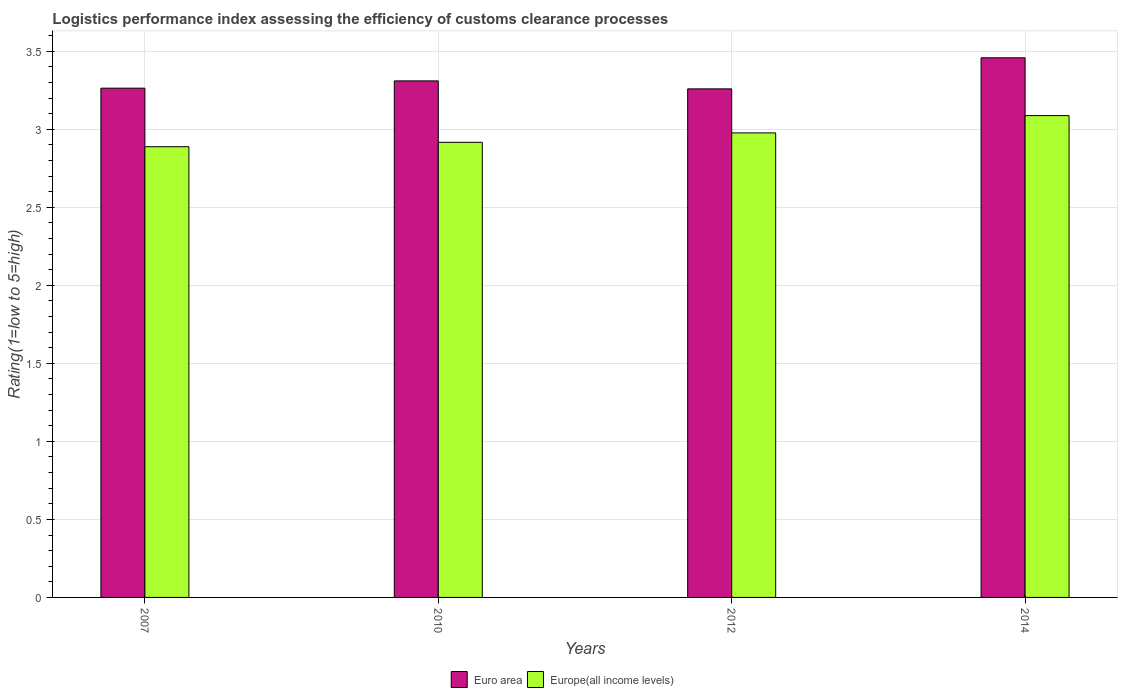How many groups of bars are there?
Provide a short and direct response. 4. How many bars are there on the 4th tick from the right?
Your answer should be compact. 2. In how many cases, is the number of bars for a given year not equal to the number of legend labels?
Keep it short and to the point. 0. What is the Logistic performance index in Euro area in 2014?
Make the answer very short. 3.46. Across all years, what is the maximum Logistic performance index in Euro area?
Keep it short and to the point. 3.46. Across all years, what is the minimum Logistic performance index in Europe(all income levels)?
Your answer should be compact. 2.89. In which year was the Logistic performance index in Euro area maximum?
Make the answer very short. 2014. What is the total Logistic performance index in Euro area in the graph?
Provide a succinct answer. 13.29. What is the difference between the Logistic performance index in Europe(all income levels) in 2010 and that in 2014?
Ensure brevity in your answer.  -0.17. What is the difference between the Logistic performance index in Europe(all income levels) in 2010 and the Logistic performance index in Euro area in 2012?
Your response must be concise. -0.34. What is the average Logistic performance index in Euro area per year?
Provide a succinct answer. 3.32. In the year 2014, what is the difference between the Logistic performance index in Euro area and Logistic performance index in Europe(all income levels)?
Keep it short and to the point. 0.37. What is the ratio of the Logistic performance index in Euro area in 2012 to that in 2014?
Your response must be concise. 0.94. Is the Logistic performance index in Europe(all income levels) in 2007 less than that in 2010?
Make the answer very short. Yes. What is the difference between the highest and the second highest Logistic performance index in Europe(all income levels)?
Offer a very short reply. 0.11. What is the difference between the highest and the lowest Logistic performance index in Euro area?
Provide a short and direct response. 0.2. In how many years, is the Logistic performance index in Euro area greater than the average Logistic performance index in Euro area taken over all years?
Your answer should be compact. 1. What does the 1st bar from the right in 2010 represents?
Give a very brief answer. Europe(all income levels). Are all the bars in the graph horizontal?
Your answer should be compact. No. How many years are there in the graph?
Ensure brevity in your answer.  4. Are the values on the major ticks of Y-axis written in scientific E-notation?
Give a very brief answer. No. Does the graph contain any zero values?
Give a very brief answer. No. What is the title of the graph?
Offer a very short reply. Logistics performance index assessing the efficiency of customs clearance processes. Does "Kosovo" appear as one of the legend labels in the graph?
Ensure brevity in your answer.  No. What is the label or title of the X-axis?
Give a very brief answer. Years. What is the label or title of the Y-axis?
Provide a short and direct response. Rating(1=low to 5=high). What is the Rating(1=low to 5=high) in Euro area in 2007?
Your response must be concise. 3.26. What is the Rating(1=low to 5=high) in Europe(all income levels) in 2007?
Make the answer very short. 2.89. What is the Rating(1=low to 5=high) of Euro area in 2010?
Make the answer very short. 3.31. What is the Rating(1=low to 5=high) of Europe(all income levels) in 2010?
Make the answer very short. 2.92. What is the Rating(1=low to 5=high) in Euro area in 2012?
Make the answer very short. 3.26. What is the Rating(1=low to 5=high) of Europe(all income levels) in 2012?
Your response must be concise. 2.98. What is the Rating(1=low to 5=high) of Euro area in 2014?
Ensure brevity in your answer.  3.46. What is the Rating(1=low to 5=high) in Europe(all income levels) in 2014?
Offer a terse response. 3.09. Across all years, what is the maximum Rating(1=low to 5=high) of Euro area?
Make the answer very short. 3.46. Across all years, what is the maximum Rating(1=low to 5=high) of Europe(all income levels)?
Your answer should be very brief. 3.09. Across all years, what is the minimum Rating(1=low to 5=high) of Euro area?
Your answer should be very brief. 3.26. Across all years, what is the minimum Rating(1=low to 5=high) in Europe(all income levels)?
Your response must be concise. 2.89. What is the total Rating(1=low to 5=high) in Euro area in the graph?
Provide a short and direct response. 13.29. What is the total Rating(1=low to 5=high) of Europe(all income levels) in the graph?
Offer a very short reply. 11.87. What is the difference between the Rating(1=low to 5=high) in Euro area in 2007 and that in 2010?
Provide a short and direct response. -0.05. What is the difference between the Rating(1=low to 5=high) in Europe(all income levels) in 2007 and that in 2010?
Your answer should be compact. -0.03. What is the difference between the Rating(1=low to 5=high) in Euro area in 2007 and that in 2012?
Offer a very short reply. 0. What is the difference between the Rating(1=low to 5=high) in Europe(all income levels) in 2007 and that in 2012?
Ensure brevity in your answer.  -0.09. What is the difference between the Rating(1=low to 5=high) of Euro area in 2007 and that in 2014?
Your answer should be compact. -0.19. What is the difference between the Rating(1=low to 5=high) in Europe(all income levels) in 2007 and that in 2014?
Your answer should be very brief. -0.2. What is the difference between the Rating(1=low to 5=high) of Euro area in 2010 and that in 2012?
Give a very brief answer. 0.05. What is the difference between the Rating(1=low to 5=high) of Europe(all income levels) in 2010 and that in 2012?
Your answer should be compact. -0.06. What is the difference between the Rating(1=low to 5=high) in Euro area in 2010 and that in 2014?
Keep it short and to the point. -0.15. What is the difference between the Rating(1=low to 5=high) in Europe(all income levels) in 2010 and that in 2014?
Your answer should be compact. -0.17. What is the difference between the Rating(1=low to 5=high) in Euro area in 2012 and that in 2014?
Provide a short and direct response. -0.2. What is the difference between the Rating(1=low to 5=high) in Europe(all income levels) in 2012 and that in 2014?
Ensure brevity in your answer.  -0.11. What is the difference between the Rating(1=low to 5=high) in Euro area in 2007 and the Rating(1=low to 5=high) in Europe(all income levels) in 2010?
Offer a terse response. 0.35. What is the difference between the Rating(1=low to 5=high) in Euro area in 2007 and the Rating(1=low to 5=high) in Europe(all income levels) in 2012?
Offer a terse response. 0.29. What is the difference between the Rating(1=low to 5=high) in Euro area in 2007 and the Rating(1=low to 5=high) in Europe(all income levels) in 2014?
Provide a short and direct response. 0.18. What is the difference between the Rating(1=low to 5=high) of Euro area in 2010 and the Rating(1=low to 5=high) of Europe(all income levels) in 2012?
Ensure brevity in your answer.  0.33. What is the difference between the Rating(1=low to 5=high) in Euro area in 2010 and the Rating(1=low to 5=high) in Europe(all income levels) in 2014?
Your response must be concise. 0.22. What is the difference between the Rating(1=low to 5=high) in Euro area in 2012 and the Rating(1=low to 5=high) in Europe(all income levels) in 2014?
Your answer should be compact. 0.17. What is the average Rating(1=low to 5=high) in Euro area per year?
Your response must be concise. 3.32. What is the average Rating(1=low to 5=high) in Europe(all income levels) per year?
Provide a short and direct response. 2.97. In the year 2007, what is the difference between the Rating(1=low to 5=high) of Euro area and Rating(1=low to 5=high) of Europe(all income levels)?
Offer a very short reply. 0.38. In the year 2010, what is the difference between the Rating(1=low to 5=high) in Euro area and Rating(1=low to 5=high) in Europe(all income levels)?
Your answer should be very brief. 0.39. In the year 2012, what is the difference between the Rating(1=low to 5=high) of Euro area and Rating(1=low to 5=high) of Europe(all income levels)?
Your answer should be compact. 0.28. In the year 2014, what is the difference between the Rating(1=low to 5=high) in Euro area and Rating(1=low to 5=high) in Europe(all income levels)?
Your answer should be compact. 0.37. What is the ratio of the Rating(1=low to 5=high) in Euro area in 2007 to that in 2010?
Make the answer very short. 0.99. What is the ratio of the Rating(1=low to 5=high) in Europe(all income levels) in 2007 to that in 2010?
Ensure brevity in your answer.  0.99. What is the ratio of the Rating(1=low to 5=high) of Europe(all income levels) in 2007 to that in 2012?
Your answer should be compact. 0.97. What is the ratio of the Rating(1=low to 5=high) in Euro area in 2007 to that in 2014?
Your answer should be very brief. 0.94. What is the ratio of the Rating(1=low to 5=high) in Europe(all income levels) in 2007 to that in 2014?
Ensure brevity in your answer.  0.94. What is the ratio of the Rating(1=low to 5=high) of Euro area in 2010 to that in 2012?
Provide a succinct answer. 1.02. What is the ratio of the Rating(1=low to 5=high) of Europe(all income levels) in 2010 to that in 2012?
Your answer should be compact. 0.98. What is the ratio of the Rating(1=low to 5=high) in Euro area in 2010 to that in 2014?
Ensure brevity in your answer.  0.96. What is the ratio of the Rating(1=low to 5=high) of Europe(all income levels) in 2010 to that in 2014?
Your response must be concise. 0.94. What is the ratio of the Rating(1=low to 5=high) of Euro area in 2012 to that in 2014?
Your answer should be compact. 0.94. What is the ratio of the Rating(1=low to 5=high) in Europe(all income levels) in 2012 to that in 2014?
Your response must be concise. 0.96. What is the difference between the highest and the second highest Rating(1=low to 5=high) in Euro area?
Keep it short and to the point. 0.15. What is the difference between the highest and the second highest Rating(1=low to 5=high) of Europe(all income levels)?
Offer a very short reply. 0.11. What is the difference between the highest and the lowest Rating(1=low to 5=high) in Euro area?
Provide a short and direct response. 0.2. What is the difference between the highest and the lowest Rating(1=low to 5=high) of Europe(all income levels)?
Offer a very short reply. 0.2. 